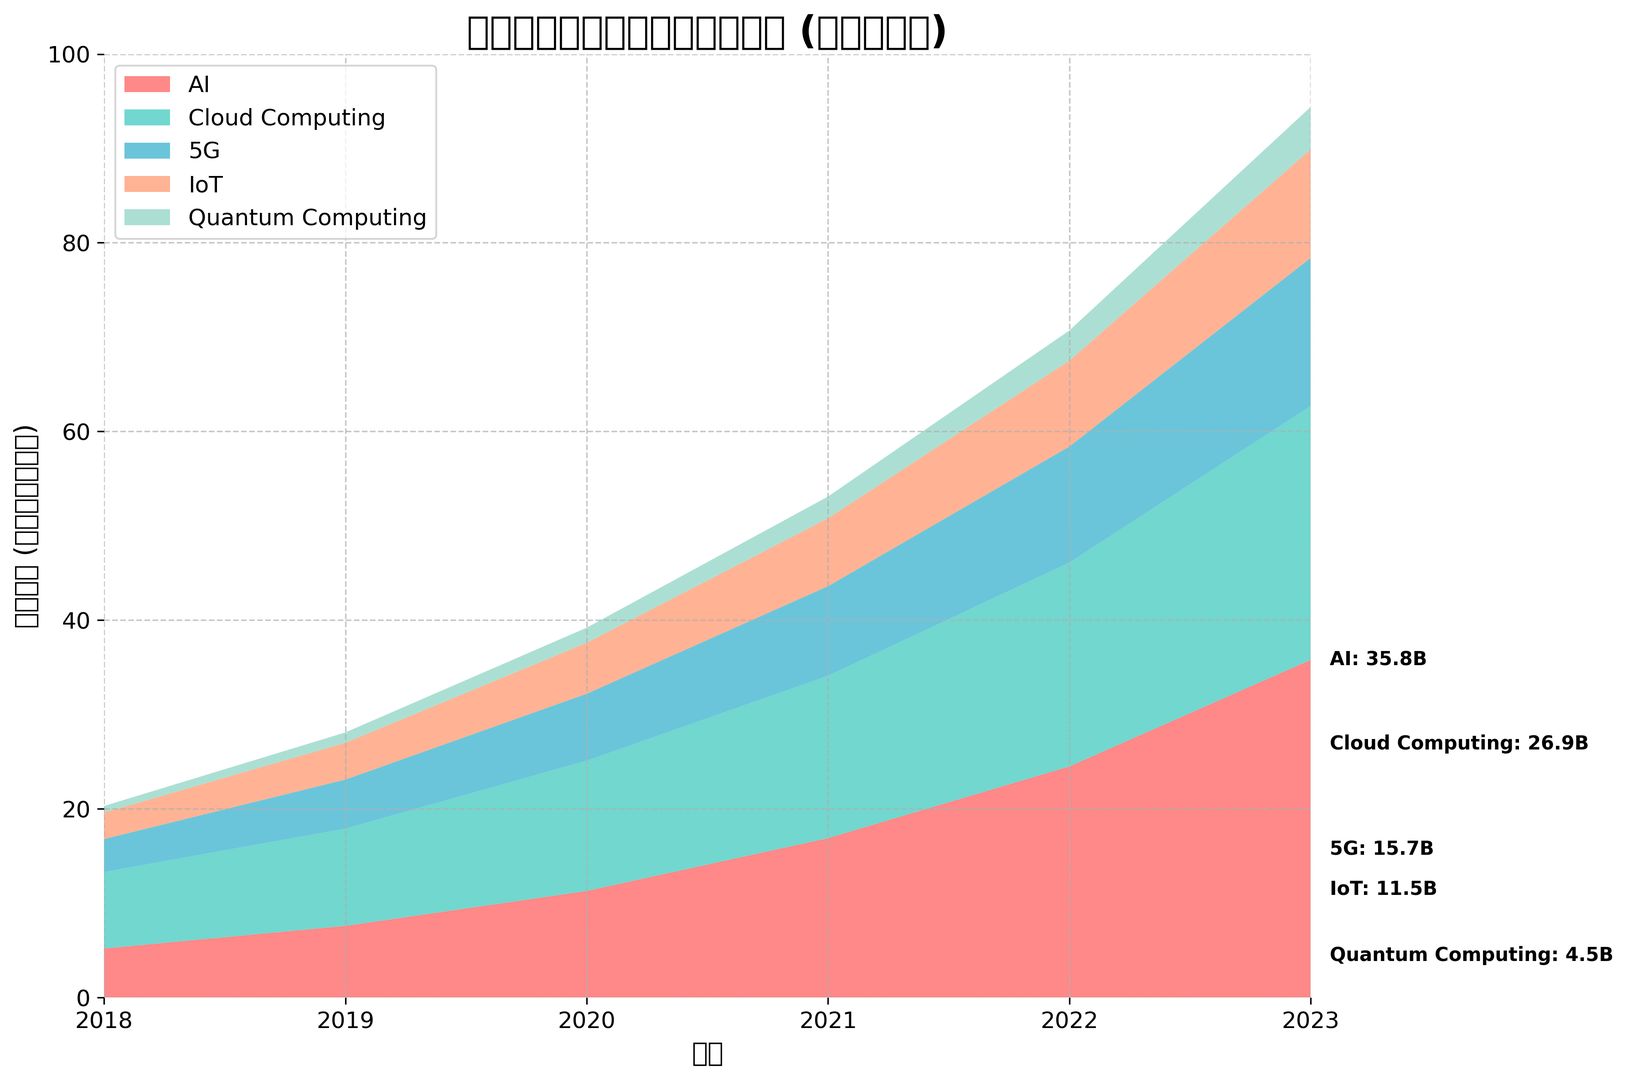哪些领域在 2023 年的研发投入最多？ 从图表中可以看到，人工智能、云计算和 5G 是 2023 年研发投入最多的三个领域。
Answer: 人工智能、云计算、5G 在 2018 年到 2023 年间，哪个领域的研发投入增长最快？ 从图表中可以看到，人工智能的研发投入从 2018 年的 5.2 亿美元增长到 2023 年的 35.8 亿美元，增长最快。
Answer: 人工智能 比较 2020 年和 2022 年，哪个领域的研发投入增幅最大？ 从图表中可以看到，人工智能从 2020 年的 11.3 亿美元增长到 2022 年的 24.5 亿美元，增幅最大。
Answer: 人工智能 量子计算的研发投入在 2019 年和 2020 年之间增加了多少？ 从图表中可以看到，量子计算的研发投入从 2019 年的 1.1 亿美元增加到 2020 年的 1.6 亿美元，增加了 0.5 亿美元。
Answer: 0.5 亿美元 哪个领域的研发投入在整个时间段内始终是最低的？ 从图表中可以看到，量子计算在所有年份中的研发投入都是最低的。
Answer: 量子计算 比较所有领域在 2018 年和 2023 年的总研发投入量，分别是多少？ 从图表中可以看到，2018 年的总研发投入为 5.2 + 8.1 + 3.5 + 2.8 + 0.7 = 20.3 亿美元，2023 年则为 35.8 + 26.9 + 15.7 + 11.5 + 4.5 = 94.4 亿美元。
Answer: 2018：20.3 亿美元，2023：94.4 亿美元 在 2023 年，物联网和 5G 的研发投入差异是多少？ 从图表中可以看到，2023 年 5G 的研发投入为 15.7 亿美元，物联网为 11.5 亿美元，差异为 15.7 - 11.5 = 4.2 亿美元。
Answer: 4.2 亿美元 相对于 2022 年，2023 年各个领域的研发投入总增长是多少？ 从图表中可以看到，2022 年的总研发投入为 24.5 + 21.6 + 12.3 + 9.1 + 3.2 = 70.7 亿美元，2023 年为 94.4 亿美元，所以总增长为 94.4 - 70.7 = 23.7 亿美元。
Answer: 23.7 亿美元 在所有领域中，哪年的量子计算研发投入数额首次超过 2 亿美元？ 从图表中可以看到，量子计算的研发投入在 2021 年达到 2.3 亿美元。
Answer: 2021 年 